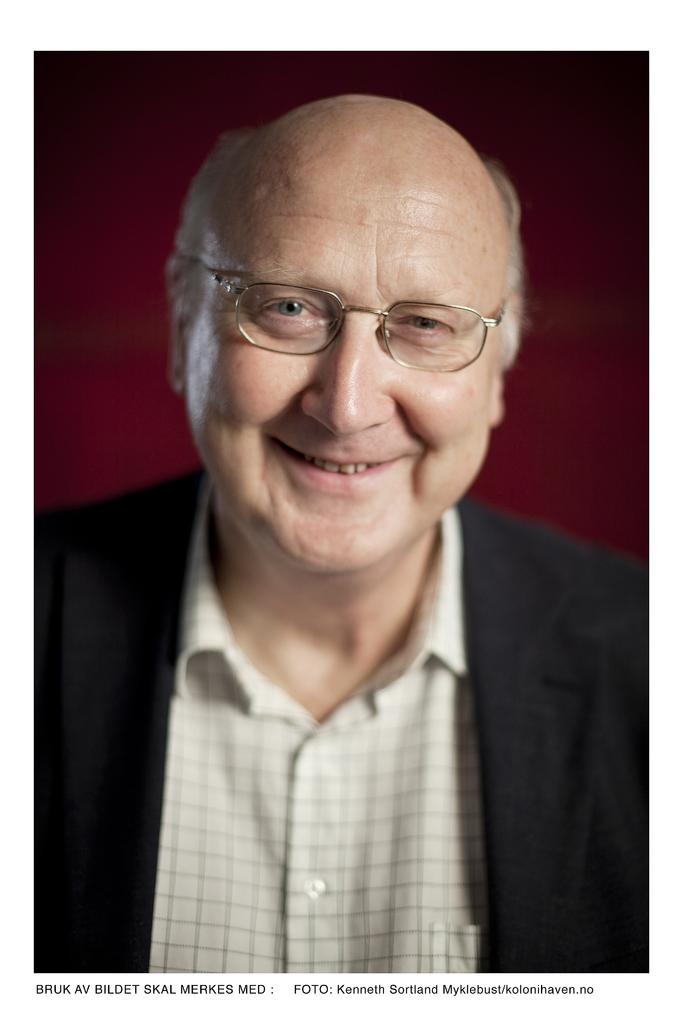What is the man in the image doing? The man in the image is smiling. What is the man wearing in the image? The man is wearing a shirt and a suit. He is also wearing spectacles. What can be observed about the man's facial expression in the image? The man is smiling in the image. What is the color of the background in the image? The background of the image appears to be maroon in color. What type of haircut does the cat in the image have? There is no cat present in the image, so it is not possible to answer that question. 